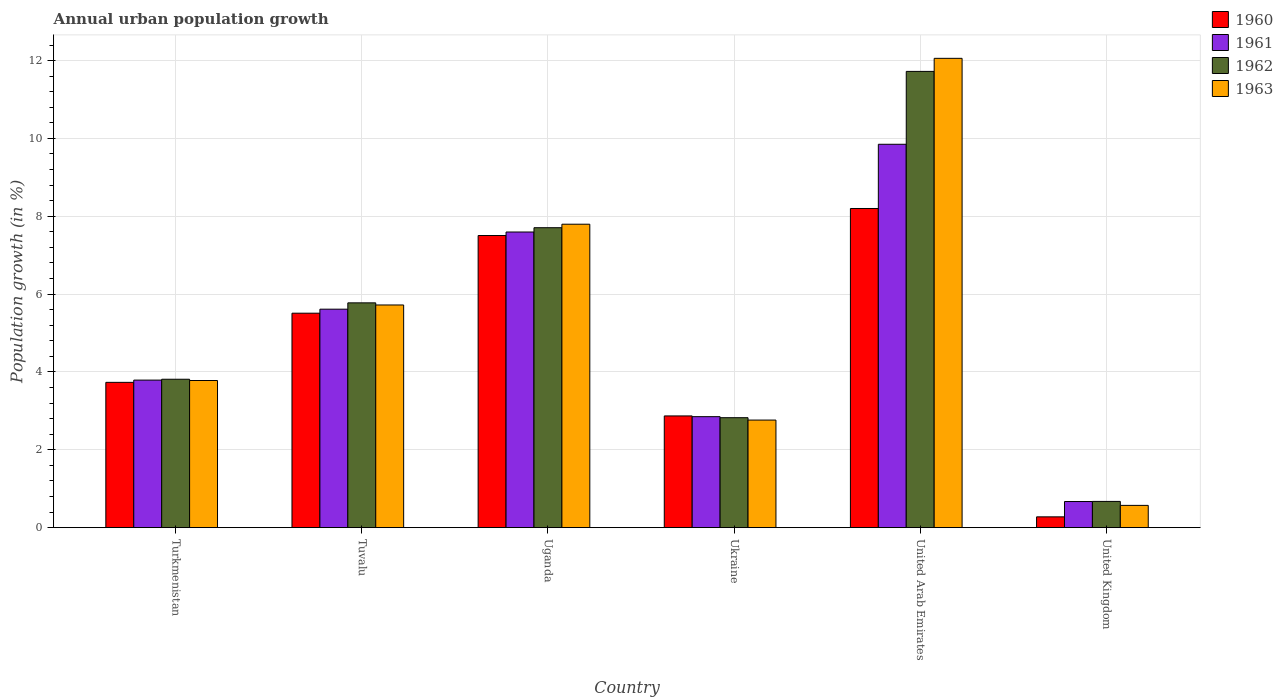How many different coloured bars are there?
Ensure brevity in your answer.  4. Are the number of bars per tick equal to the number of legend labels?
Your answer should be compact. Yes. Are the number of bars on each tick of the X-axis equal?
Make the answer very short. Yes. What is the label of the 2nd group of bars from the left?
Provide a succinct answer. Tuvalu. What is the percentage of urban population growth in 1960 in Ukraine?
Your answer should be compact. 2.87. Across all countries, what is the maximum percentage of urban population growth in 1962?
Offer a very short reply. 11.72. Across all countries, what is the minimum percentage of urban population growth in 1960?
Offer a terse response. 0.28. In which country was the percentage of urban population growth in 1963 maximum?
Provide a short and direct response. United Arab Emirates. What is the total percentage of urban population growth in 1963 in the graph?
Keep it short and to the point. 32.69. What is the difference between the percentage of urban population growth in 1963 in Ukraine and that in United Arab Emirates?
Give a very brief answer. -9.29. What is the difference between the percentage of urban population growth in 1960 in United Kingdom and the percentage of urban population growth in 1963 in Uganda?
Provide a succinct answer. -7.52. What is the average percentage of urban population growth in 1960 per country?
Provide a succinct answer. 4.68. What is the difference between the percentage of urban population growth of/in 1961 and percentage of urban population growth of/in 1963 in Ukraine?
Ensure brevity in your answer.  0.09. In how many countries, is the percentage of urban population growth in 1961 greater than 6 %?
Provide a short and direct response. 2. What is the ratio of the percentage of urban population growth in 1963 in Uganda to that in Ukraine?
Your answer should be compact. 2.82. What is the difference between the highest and the second highest percentage of urban population growth in 1962?
Your answer should be compact. 5.95. What is the difference between the highest and the lowest percentage of urban population growth in 1962?
Keep it short and to the point. 11.05. Is the sum of the percentage of urban population growth in 1963 in Turkmenistan and Ukraine greater than the maximum percentage of urban population growth in 1960 across all countries?
Offer a very short reply. No. What does the 4th bar from the left in United Kingdom represents?
Offer a very short reply. 1963. What does the 1st bar from the right in Turkmenistan represents?
Provide a succinct answer. 1963. How many countries are there in the graph?
Your response must be concise. 6. What is the difference between two consecutive major ticks on the Y-axis?
Your answer should be very brief. 2. Are the values on the major ticks of Y-axis written in scientific E-notation?
Provide a succinct answer. No. How many legend labels are there?
Ensure brevity in your answer.  4. How are the legend labels stacked?
Offer a very short reply. Vertical. What is the title of the graph?
Offer a terse response. Annual urban population growth. What is the label or title of the X-axis?
Provide a short and direct response. Country. What is the label or title of the Y-axis?
Provide a succinct answer. Population growth (in %). What is the Population growth (in %) of 1960 in Turkmenistan?
Your response must be concise. 3.73. What is the Population growth (in %) in 1961 in Turkmenistan?
Offer a very short reply. 3.79. What is the Population growth (in %) in 1962 in Turkmenistan?
Make the answer very short. 3.81. What is the Population growth (in %) in 1963 in Turkmenistan?
Make the answer very short. 3.78. What is the Population growth (in %) of 1960 in Tuvalu?
Offer a very short reply. 5.51. What is the Population growth (in %) in 1961 in Tuvalu?
Ensure brevity in your answer.  5.61. What is the Population growth (in %) of 1962 in Tuvalu?
Provide a short and direct response. 5.78. What is the Population growth (in %) of 1963 in Tuvalu?
Your answer should be very brief. 5.72. What is the Population growth (in %) of 1960 in Uganda?
Ensure brevity in your answer.  7.51. What is the Population growth (in %) in 1961 in Uganda?
Provide a succinct answer. 7.6. What is the Population growth (in %) in 1962 in Uganda?
Your answer should be very brief. 7.71. What is the Population growth (in %) in 1963 in Uganda?
Offer a terse response. 7.8. What is the Population growth (in %) of 1960 in Ukraine?
Provide a succinct answer. 2.87. What is the Population growth (in %) of 1961 in Ukraine?
Your answer should be compact. 2.85. What is the Population growth (in %) of 1962 in Ukraine?
Give a very brief answer. 2.82. What is the Population growth (in %) of 1963 in Ukraine?
Offer a terse response. 2.76. What is the Population growth (in %) of 1960 in United Arab Emirates?
Provide a succinct answer. 8.2. What is the Population growth (in %) in 1961 in United Arab Emirates?
Provide a short and direct response. 9.85. What is the Population growth (in %) of 1962 in United Arab Emirates?
Provide a short and direct response. 11.72. What is the Population growth (in %) of 1963 in United Arab Emirates?
Your answer should be very brief. 12.06. What is the Population growth (in %) of 1960 in United Kingdom?
Make the answer very short. 0.28. What is the Population growth (in %) of 1961 in United Kingdom?
Make the answer very short. 0.67. What is the Population growth (in %) in 1962 in United Kingdom?
Offer a terse response. 0.67. What is the Population growth (in %) of 1963 in United Kingdom?
Your response must be concise. 0.57. Across all countries, what is the maximum Population growth (in %) of 1960?
Offer a very short reply. 8.2. Across all countries, what is the maximum Population growth (in %) in 1961?
Your answer should be very brief. 9.85. Across all countries, what is the maximum Population growth (in %) in 1962?
Your answer should be very brief. 11.72. Across all countries, what is the maximum Population growth (in %) of 1963?
Provide a succinct answer. 12.06. Across all countries, what is the minimum Population growth (in %) in 1960?
Offer a terse response. 0.28. Across all countries, what is the minimum Population growth (in %) of 1961?
Offer a terse response. 0.67. Across all countries, what is the minimum Population growth (in %) of 1962?
Your answer should be very brief. 0.67. Across all countries, what is the minimum Population growth (in %) of 1963?
Make the answer very short. 0.57. What is the total Population growth (in %) of 1960 in the graph?
Provide a succinct answer. 28.1. What is the total Population growth (in %) of 1961 in the graph?
Keep it short and to the point. 30.37. What is the total Population growth (in %) in 1962 in the graph?
Keep it short and to the point. 32.51. What is the total Population growth (in %) in 1963 in the graph?
Offer a very short reply. 32.69. What is the difference between the Population growth (in %) of 1960 in Turkmenistan and that in Tuvalu?
Keep it short and to the point. -1.78. What is the difference between the Population growth (in %) in 1961 in Turkmenistan and that in Tuvalu?
Make the answer very short. -1.82. What is the difference between the Population growth (in %) in 1962 in Turkmenistan and that in Tuvalu?
Keep it short and to the point. -1.96. What is the difference between the Population growth (in %) of 1963 in Turkmenistan and that in Tuvalu?
Your response must be concise. -1.94. What is the difference between the Population growth (in %) of 1960 in Turkmenistan and that in Uganda?
Offer a terse response. -3.77. What is the difference between the Population growth (in %) in 1961 in Turkmenistan and that in Uganda?
Provide a succinct answer. -3.8. What is the difference between the Population growth (in %) of 1962 in Turkmenistan and that in Uganda?
Offer a terse response. -3.89. What is the difference between the Population growth (in %) of 1963 in Turkmenistan and that in Uganda?
Your answer should be compact. -4.02. What is the difference between the Population growth (in %) in 1960 in Turkmenistan and that in Ukraine?
Ensure brevity in your answer.  0.86. What is the difference between the Population growth (in %) in 1961 in Turkmenistan and that in Ukraine?
Offer a very short reply. 0.94. What is the difference between the Population growth (in %) of 1962 in Turkmenistan and that in Ukraine?
Give a very brief answer. 0.99. What is the difference between the Population growth (in %) of 1963 in Turkmenistan and that in Ukraine?
Your answer should be compact. 1.02. What is the difference between the Population growth (in %) in 1960 in Turkmenistan and that in United Arab Emirates?
Provide a succinct answer. -4.47. What is the difference between the Population growth (in %) in 1961 in Turkmenistan and that in United Arab Emirates?
Offer a very short reply. -6.06. What is the difference between the Population growth (in %) in 1962 in Turkmenistan and that in United Arab Emirates?
Make the answer very short. -7.91. What is the difference between the Population growth (in %) in 1963 in Turkmenistan and that in United Arab Emirates?
Keep it short and to the point. -8.28. What is the difference between the Population growth (in %) of 1960 in Turkmenistan and that in United Kingdom?
Offer a terse response. 3.46. What is the difference between the Population growth (in %) in 1961 in Turkmenistan and that in United Kingdom?
Your answer should be compact. 3.12. What is the difference between the Population growth (in %) in 1962 in Turkmenistan and that in United Kingdom?
Your response must be concise. 3.14. What is the difference between the Population growth (in %) in 1963 in Turkmenistan and that in United Kingdom?
Provide a succinct answer. 3.21. What is the difference between the Population growth (in %) in 1960 in Tuvalu and that in Uganda?
Your answer should be compact. -2. What is the difference between the Population growth (in %) of 1961 in Tuvalu and that in Uganda?
Keep it short and to the point. -1.98. What is the difference between the Population growth (in %) of 1962 in Tuvalu and that in Uganda?
Provide a succinct answer. -1.93. What is the difference between the Population growth (in %) in 1963 in Tuvalu and that in Uganda?
Provide a short and direct response. -2.08. What is the difference between the Population growth (in %) in 1960 in Tuvalu and that in Ukraine?
Ensure brevity in your answer.  2.64. What is the difference between the Population growth (in %) of 1961 in Tuvalu and that in Ukraine?
Offer a terse response. 2.76. What is the difference between the Population growth (in %) of 1962 in Tuvalu and that in Ukraine?
Offer a very short reply. 2.95. What is the difference between the Population growth (in %) of 1963 in Tuvalu and that in Ukraine?
Make the answer very short. 2.96. What is the difference between the Population growth (in %) of 1960 in Tuvalu and that in United Arab Emirates?
Your answer should be very brief. -2.69. What is the difference between the Population growth (in %) in 1961 in Tuvalu and that in United Arab Emirates?
Give a very brief answer. -4.24. What is the difference between the Population growth (in %) of 1962 in Tuvalu and that in United Arab Emirates?
Provide a short and direct response. -5.95. What is the difference between the Population growth (in %) in 1963 in Tuvalu and that in United Arab Emirates?
Your answer should be compact. -6.34. What is the difference between the Population growth (in %) in 1960 in Tuvalu and that in United Kingdom?
Make the answer very short. 5.23. What is the difference between the Population growth (in %) in 1961 in Tuvalu and that in United Kingdom?
Offer a terse response. 4.94. What is the difference between the Population growth (in %) in 1962 in Tuvalu and that in United Kingdom?
Your response must be concise. 5.1. What is the difference between the Population growth (in %) in 1963 in Tuvalu and that in United Kingdom?
Provide a succinct answer. 5.15. What is the difference between the Population growth (in %) in 1960 in Uganda and that in Ukraine?
Ensure brevity in your answer.  4.64. What is the difference between the Population growth (in %) in 1961 in Uganda and that in Ukraine?
Keep it short and to the point. 4.74. What is the difference between the Population growth (in %) in 1962 in Uganda and that in Ukraine?
Give a very brief answer. 4.88. What is the difference between the Population growth (in %) of 1963 in Uganda and that in Ukraine?
Offer a very short reply. 5.03. What is the difference between the Population growth (in %) in 1960 in Uganda and that in United Arab Emirates?
Your answer should be very brief. -0.69. What is the difference between the Population growth (in %) in 1961 in Uganda and that in United Arab Emirates?
Provide a short and direct response. -2.25. What is the difference between the Population growth (in %) of 1962 in Uganda and that in United Arab Emirates?
Provide a succinct answer. -4.02. What is the difference between the Population growth (in %) in 1963 in Uganda and that in United Arab Emirates?
Provide a succinct answer. -4.26. What is the difference between the Population growth (in %) of 1960 in Uganda and that in United Kingdom?
Your response must be concise. 7.23. What is the difference between the Population growth (in %) of 1961 in Uganda and that in United Kingdom?
Provide a short and direct response. 6.92. What is the difference between the Population growth (in %) of 1962 in Uganda and that in United Kingdom?
Your answer should be compact. 7.03. What is the difference between the Population growth (in %) of 1963 in Uganda and that in United Kingdom?
Provide a short and direct response. 7.22. What is the difference between the Population growth (in %) in 1960 in Ukraine and that in United Arab Emirates?
Give a very brief answer. -5.33. What is the difference between the Population growth (in %) in 1961 in Ukraine and that in United Arab Emirates?
Your response must be concise. -7. What is the difference between the Population growth (in %) in 1962 in Ukraine and that in United Arab Emirates?
Ensure brevity in your answer.  -8.9. What is the difference between the Population growth (in %) of 1963 in Ukraine and that in United Arab Emirates?
Provide a short and direct response. -9.29. What is the difference between the Population growth (in %) in 1960 in Ukraine and that in United Kingdom?
Make the answer very short. 2.59. What is the difference between the Population growth (in %) of 1961 in Ukraine and that in United Kingdom?
Give a very brief answer. 2.18. What is the difference between the Population growth (in %) in 1962 in Ukraine and that in United Kingdom?
Provide a succinct answer. 2.15. What is the difference between the Population growth (in %) of 1963 in Ukraine and that in United Kingdom?
Your response must be concise. 2.19. What is the difference between the Population growth (in %) of 1960 in United Arab Emirates and that in United Kingdom?
Your answer should be compact. 7.92. What is the difference between the Population growth (in %) of 1961 in United Arab Emirates and that in United Kingdom?
Your answer should be compact. 9.18. What is the difference between the Population growth (in %) of 1962 in United Arab Emirates and that in United Kingdom?
Your answer should be very brief. 11.05. What is the difference between the Population growth (in %) of 1963 in United Arab Emirates and that in United Kingdom?
Provide a succinct answer. 11.49. What is the difference between the Population growth (in %) in 1960 in Turkmenistan and the Population growth (in %) in 1961 in Tuvalu?
Your answer should be very brief. -1.88. What is the difference between the Population growth (in %) of 1960 in Turkmenistan and the Population growth (in %) of 1962 in Tuvalu?
Keep it short and to the point. -2.04. What is the difference between the Population growth (in %) of 1960 in Turkmenistan and the Population growth (in %) of 1963 in Tuvalu?
Offer a terse response. -1.99. What is the difference between the Population growth (in %) of 1961 in Turkmenistan and the Population growth (in %) of 1962 in Tuvalu?
Your answer should be very brief. -1.98. What is the difference between the Population growth (in %) in 1961 in Turkmenistan and the Population growth (in %) in 1963 in Tuvalu?
Your answer should be compact. -1.93. What is the difference between the Population growth (in %) in 1962 in Turkmenistan and the Population growth (in %) in 1963 in Tuvalu?
Make the answer very short. -1.91. What is the difference between the Population growth (in %) in 1960 in Turkmenistan and the Population growth (in %) in 1961 in Uganda?
Offer a terse response. -3.86. What is the difference between the Population growth (in %) of 1960 in Turkmenistan and the Population growth (in %) of 1962 in Uganda?
Offer a very short reply. -3.97. What is the difference between the Population growth (in %) in 1960 in Turkmenistan and the Population growth (in %) in 1963 in Uganda?
Your answer should be very brief. -4.06. What is the difference between the Population growth (in %) in 1961 in Turkmenistan and the Population growth (in %) in 1962 in Uganda?
Offer a terse response. -3.92. What is the difference between the Population growth (in %) in 1961 in Turkmenistan and the Population growth (in %) in 1963 in Uganda?
Give a very brief answer. -4.01. What is the difference between the Population growth (in %) of 1962 in Turkmenistan and the Population growth (in %) of 1963 in Uganda?
Offer a very short reply. -3.98. What is the difference between the Population growth (in %) in 1960 in Turkmenistan and the Population growth (in %) in 1961 in Ukraine?
Your answer should be compact. 0.88. What is the difference between the Population growth (in %) in 1960 in Turkmenistan and the Population growth (in %) in 1962 in Ukraine?
Give a very brief answer. 0.91. What is the difference between the Population growth (in %) of 1960 in Turkmenistan and the Population growth (in %) of 1963 in Ukraine?
Your response must be concise. 0.97. What is the difference between the Population growth (in %) of 1961 in Turkmenistan and the Population growth (in %) of 1962 in Ukraine?
Give a very brief answer. 0.97. What is the difference between the Population growth (in %) in 1962 in Turkmenistan and the Population growth (in %) in 1963 in Ukraine?
Offer a terse response. 1.05. What is the difference between the Population growth (in %) in 1960 in Turkmenistan and the Population growth (in %) in 1961 in United Arab Emirates?
Offer a terse response. -6.12. What is the difference between the Population growth (in %) of 1960 in Turkmenistan and the Population growth (in %) of 1962 in United Arab Emirates?
Give a very brief answer. -7.99. What is the difference between the Population growth (in %) of 1960 in Turkmenistan and the Population growth (in %) of 1963 in United Arab Emirates?
Your answer should be compact. -8.32. What is the difference between the Population growth (in %) in 1961 in Turkmenistan and the Population growth (in %) in 1962 in United Arab Emirates?
Offer a terse response. -7.93. What is the difference between the Population growth (in %) of 1961 in Turkmenistan and the Population growth (in %) of 1963 in United Arab Emirates?
Make the answer very short. -8.27. What is the difference between the Population growth (in %) of 1962 in Turkmenistan and the Population growth (in %) of 1963 in United Arab Emirates?
Ensure brevity in your answer.  -8.24. What is the difference between the Population growth (in %) in 1960 in Turkmenistan and the Population growth (in %) in 1961 in United Kingdom?
Your answer should be compact. 3.06. What is the difference between the Population growth (in %) in 1960 in Turkmenistan and the Population growth (in %) in 1962 in United Kingdom?
Keep it short and to the point. 3.06. What is the difference between the Population growth (in %) of 1960 in Turkmenistan and the Population growth (in %) of 1963 in United Kingdom?
Give a very brief answer. 3.16. What is the difference between the Population growth (in %) of 1961 in Turkmenistan and the Population growth (in %) of 1962 in United Kingdom?
Ensure brevity in your answer.  3.12. What is the difference between the Population growth (in %) of 1961 in Turkmenistan and the Population growth (in %) of 1963 in United Kingdom?
Your response must be concise. 3.22. What is the difference between the Population growth (in %) in 1962 in Turkmenistan and the Population growth (in %) in 1963 in United Kingdom?
Your answer should be very brief. 3.24. What is the difference between the Population growth (in %) of 1960 in Tuvalu and the Population growth (in %) of 1961 in Uganda?
Your response must be concise. -2.09. What is the difference between the Population growth (in %) in 1960 in Tuvalu and the Population growth (in %) in 1962 in Uganda?
Offer a terse response. -2.2. What is the difference between the Population growth (in %) of 1960 in Tuvalu and the Population growth (in %) of 1963 in Uganda?
Keep it short and to the point. -2.29. What is the difference between the Population growth (in %) in 1961 in Tuvalu and the Population growth (in %) in 1962 in Uganda?
Offer a very short reply. -2.09. What is the difference between the Population growth (in %) in 1961 in Tuvalu and the Population growth (in %) in 1963 in Uganda?
Offer a terse response. -2.18. What is the difference between the Population growth (in %) in 1962 in Tuvalu and the Population growth (in %) in 1963 in Uganda?
Offer a very short reply. -2.02. What is the difference between the Population growth (in %) of 1960 in Tuvalu and the Population growth (in %) of 1961 in Ukraine?
Provide a short and direct response. 2.66. What is the difference between the Population growth (in %) of 1960 in Tuvalu and the Population growth (in %) of 1962 in Ukraine?
Give a very brief answer. 2.69. What is the difference between the Population growth (in %) in 1960 in Tuvalu and the Population growth (in %) in 1963 in Ukraine?
Provide a succinct answer. 2.75. What is the difference between the Population growth (in %) of 1961 in Tuvalu and the Population growth (in %) of 1962 in Ukraine?
Keep it short and to the point. 2.79. What is the difference between the Population growth (in %) of 1961 in Tuvalu and the Population growth (in %) of 1963 in Ukraine?
Your response must be concise. 2.85. What is the difference between the Population growth (in %) in 1962 in Tuvalu and the Population growth (in %) in 1963 in Ukraine?
Your answer should be compact. 3.01. What is the difference between the Population growth (in %) in 1960 in Tuvalu and the Population growth (in %) in 1961 in United Arab Emirates?
Make the answer very short. -4.34. What is the difference between the Population growth (in %) in 1960 in Tuvalu and the Population growth (in %) in 1962 in United Arab Emirates?
Provide a succinct answer. -6.21. What is the difference between the Population growth (in %) of 1960 in Tuvalu and the Population growth (in %) of 1963 in United Arab Emirates?
Your response must be concise. -6.55. What is the difference between the Population growth (in %) in 1961 in Tuvalu and the Population growth (in %) in 1962 in United Arab Emirates?
Keep it short and to the point. -6.11. What is the difference between the Population growth (in %) of 1961 in Tuvalu and the Population growth (in %) of 1963 in United Arab Emirates?
Offer a terse response. -6.44. What is the difference between the Population growth (in %) of 1962 in Tuvalu and the Population growth (in %) of 1963 in United Arab Emirates?
Provide a short and direct response. -6.28. What is the difference between the Population growth (in %) in 1960 in Tuvalu and the Population growth (in %) in 1961 in United Kingdom?
Offer a terse response. 4.84. What is the difference between the Population growth (in %) in 1960 in Tuvalu and the Population growth (in %) in 1962 in United Kingdom?
Offer a very short reply. 4.84. What is the difference between the Population growth (in %) of 1960 in Tuvalu and the Population growth (in %) of 1963 in United Kingdom?
Your answer should be compact. 4.94. What is the difference between the Population growth (in %) of 1961 in Tuvalu and the Population growth (in %) of 1962 in United Kingdom?
Your response must be concise. 4.94. What is the difference between the Population growth (in %) in 1961 in Tuvalu and the Population growth (in %) in 1963 in United Kingdom?
Provide a short and direct response. 5.04. What is the difference between the Population growth (in %) in 1962 in Tuvalu and the Population growth (in %) in 1963 in United Kingdom?
Give a very brief answer. 5.2. What is the difference between the Population growth (in %) in 1960 in Uganda and the Population growth (in %) in 1961 in Ukraine?
Your answer should be compact. 4.65. What is the difference between the Population growth (in %) of 1960 in Uganda and the Population growth (in %) of 1962 in Ukraine?
Provide a succinct answer. 4.68. What is the difference between the Population growth (in %) of 1960 in Uganda and the Population growth (in %) of 1963 in Ukraine?
Offer a very short reply. 4.74. What is the difference between the Population growth (in %) in 1961 in Uganda and the Population growth (in %) in 1962 in Ukraine?
Ensure brevity in your answer.  4.77. What is the difference between the Population growth (in %) in 1961 in Uganda and the Population growth (in %) in 1963 in Ukraine?
Offer a terse response. 4.83. What is the difference between the Population growth (in %) in 1962 in Uganda and the Population growth (in %) in 1963 in Ukraine?
Offer a very short reply. 4.94. What is the difference between the Population growth (in %) of 1960 in Uganda and the Population growth (in %) of 1961 in United Arab Emirates?
Ensure brevity in your answer.  -2.34. What is the difference between the Population growth (in %) in 1960 in Uganda and the Population growth (in %) in 1962 in United Arab Emirates?
Keep it short and to the point. -4.22. What is the difference between the Population growth (in %) of 1960 in Uganda and the Population growth (in %) of 1963 in United Arab Emirates?
Provide a short and direct response. -4.55. What is the difference between the Population growth (in %) of 1961 in Uganda and the Population growth (in %) of 1962 in United Arab Emirates?
Make the answer very short. -4.13. What is the difference between the Population growth (in %) of 1961 in Uganda and the Population growth (in %) of 1963 in United Arab Emirates?
Ensure brevity in your answer.  -4.46. What is the difference between the Population growth (in %) of 1962 in Uganda and the Population growth (in %) of 1963 in United Arab Emirates?
Keep it short and to the point. -4.35. What is the difference between the Population growth (in %) of 1960 in Uganda and the Population growth (in %) of 1961 in United Kingdom?
Your answer should be very brief. 6.83. What is the difference between the Population growth (in %) of 1960 in Uganda and the Population growth (in %) of 1962 in United Kingdom?
Your answer should be very brief. 6.83. What is the difference between the Population growth (in %) of 1960 in Uganda and the Population growth (in %) of 1963 in United Kingdom?
Your answer should be very brief. 6.93. What is the difference between the Population growth (in %) of 1961 in Uganda and the Population growth (in %) of 1962 in United Kingdom?
Offer a very short reply. 6.92. What is the difference between the Population growth (in %) in 1961 in Uganda and the Population growth (in %) in 1963 in United Kingdom?
Ensure brevity in your answer.  7.02. What is the difference between the Population growth (in %) in 1962 in Uganda and the Population growth (in %) in 1963 in United Kingdom?
Make the answer very short. 7.13. What is the difference between the Population growth (in %) of 1960 in Ukraine and the Population growth (in %) of 1961 in United Arab Emirates?
Give a very brief answer. -6.98. What is the difference between the Population growth (in %) of 1960 in Ukraine and the Population growth (in %) of 1962 in United Arab Emirates?
Make the answer very short. -8.85. What is the difference between the Population growth (in %) in 1960 in Ukraine and the Population growth (in %) in 1963 in United Arab Emirates?
Ensure brevity in your answer.  -9.19. What is the difference between the Population growth (in %) in 1961 in Ukraine and the Population growth (in %) in 1962 in United Arab Emirates?
Ensure brevity in your answer.  -8.87. What is the difference between the Population growth (in %) in 1961 in Ukraine and the Population growth (in %) in 1963 in United Arab Emirates?
Make the answer very short. -9.21. What is the difference between the Population growth (in %) in 1962 in Ukraine and the Population growth (in %) in 1963 in United Arab Emirates?
Your answer should be compact. -9.23. What is the difference between the Population growth (in %) in 1960 in Ukraine and the Population growth (in %) in 1961 in United Kingdom?
Provide a succinct answer. 2.2. What is the difference between the Population growth (in %) in 1960 in Ukraine and the Population growth (in %) in 1962 in United Kingdom?
Your response must be concise. 2.2. What is the difference between the Population growth (in %) in 1960 in Ukraine and the Population growth (in %) in 1963 in United Kingdom?
Ensure brevity in your answer.  2.3. What is the difference between the Population growth (in %) of 1961 in Ukraine and the Population growth (in %) of 1962 in United Kingdom?
Provide a succinct answer. 2.18. What is the difference between the Population growth (in %) in 1961 in Ukraine and the Population growth (in %) in 1963 in United Kingdom?
Provide a succinct answer. 2.28. What is the difference between the Population growth (in %) in 1962 in Ukraine and the Population growth (in %) in 1963 in United Kingdom?
Your answer should be very brief. 2.25. What is the difference between the Population growth (in %) in 1960 in United Arab Emirates and the Population growth (in %) in 1961 in United Kingdom?
Keep it short and to the point. 7.53. What is the difference between the Population growth (in %) of 1960 in United Arab Emirates and the Population growth (in %) of 1962 in United Kingdom?
Your answer should be very brief. 7.53. What is the difference between the Population growth (in %) in 1960 in United Arab Emirates and the Population growth (in %) in 1963 in United Kingdom?
Provide a short and direct response. 7.63. What is the difference between the Population growth (in %) in 1961 in United Arab Emirates and the Population growth (in %) in 1962 in United Kingdom?
Ensure brevity in your answer.  9.18. What is the difference between the Population growth (in %) in 1961 in United Arab Emirates and the Population growth (in %) in 1963 in United Kingdom?
Offer a terse response. 9.28. What is the difference between the Population growth (in %) in 1962 in United Arab Emirates and the Population growth (in %) in 1963 in United Kingdom?
Your answer should be compact. 11.15. What is the average Population growth (in %) in 1960 per country?
Your answer should be very brief. 4.68. What is the average Population growth (in %) in 1961 per country?
Provide a short and direct response. 5.06. What is the average Population growth (in %) in 1962 per country?
Make the answer very short. 5.42. What is the average Population growth (in %) in 1963 per country?
Your answer should be compact. 5.45. What is the difference between the Population growth (in %) of 1960 and Population growth (in %) of 1961 in Turkmenistan?
Offer a terse response. -0.06. What is the difference between the Population growth (in %) in 1960 and Population growth (in %) in 1962 in Turkmenistan?
Ensure brevity in your answer.  -0.08. What is the difference between the Population growth (in %) of 1960 and Population growth (in %) of 1963 in Turkmenistan?
Make the answer very short. -0.05. What is the difference between the Population growth (in %) in 1961 and Population growth (in %) in 1962 in Turkmenistan?
Your answer should be compact. -0.02. What is the difference between the Population growth (in %) in 1961 and Population growth (in %) in 1963 in Turkmenistan?
Keep it short and to the point. 0.01. What is the difference between the Population growth (in %) in 1962 and Population growth (in %) in 1963 in Turkmenistan?
Your response must be concise. 0.03. What is the difference between the Population growth (in %) in 1960 and Population growth (in %) in 1961 in Tuvalu?
Keep it short and to the point. -0.1. What is the difference between the Population growth (in %) of 1960 and Population growth (in %) of 1962 in Tuvalu?
Offer a terse response. -0.27. What is the difference between the Population growth (in %) in 1960 and Population growth (in %) in 1963 in Tuvalu?
Give a very brief answer. -0.21. What is the difference between the Population growth (in %) of 1961 and Population growth (in %) of 1962 in Tuvalu?
Ensure brevity in your answer.  -0.16. What is the difference between the Population growth (in %) of 1961 and Population growth (in %) of 1963 in Tuvalu?
Give a very brief answer. -0.11. What is the difference between the Population growth (in %) in 1962 and Population growth (in %) in 1963 in Tuvalu?
Provide a succinct answer. 0.05. What is the difference between the Population growth (in %) of 1960 and Population growth (in %) of 1961 in Uganda?
Provide a short and direct response. -0.09. What is the difference between the Population growth (in %) of 1960 and Population growth (in %) of 1962 in Uganda?
Ensure brevity in your answer.  -0.2. What is the difference between the Population growth (in %) of 1960 and Population growth (in %) of 1963 in Uganda?
Provide a succinct answer. -0.29. What is the difference between the Population growth (in %) of 1961 and Population growth (in %) of 1962 in Uganda?
Your answer should be compact. -0.11. What is the difference between the Population growth (in %) of 1961 and Population growth (in %) of 1963 in Uganda?
Give a very brief answer. -0.2. What is the difference between the Population growth (in %) of 1962 and Population growth (in %) of 1963 in Uganda?
Ensure brevity in your answer.  -0.09. What is the difference between the Population growth (in %) of 1960 and Population growth (in %) of 1961 in Ukraine?
Your answer should be very brief. 0.02. What is the difference between the Population growth (in %) of 1960 and Population growth (in %) of 1962 in Ukraine?
Ensure brevity in your answer.  0.05. What is the difference between the Population growth (in %) in 1960 and Population growth (in %) in 1963 in Ukraine?
Ensure brevity in your answer.  0.11. What is the difference between the Population growth (in %) of 1961 and Population growth (in %) of 1962 in Ukraine?
Your answer should be compact. 0.03. What is the difference between the Population growth (in %) in 1961 and Population growth (in %) in 1963 in Ukraine?
Give a very brief answer. 0.09. What is the difference between the Population growth (in %) in 1962 and Population growth (in %) in 1963 in Ukraine?
Provide a short and direct response. 0.06. What is the difference between the Population growth (in %) of 1960 and Population growth (in %) of 1961 in United Arab Emirates?
Make the answer very short. -1.65. What is the difference between the Population growth (in %) of 1960 and Population growth (in %) of 1962 in United Arab Emirates?
Make the answer very short. -3.52. What is the difference between the Population growth (in %) in 1960 and Population growth (in %) in 1963 in United Arab Emirates?
Provide a succinct answer. -3.86. What is the difference between the Population growth (in %) of 1961 and Population growth (in %) of 1962 in United Arab Emirates?
Your answer should be compact. -1.87. What is the difference between the Population growth (in %) of 1961 and Population growth (in %) of 1963 in United Arab Emirates?
Your answer should be very brief. -2.21. What is the difference between the Population growth (in %) of 1962 and Population growth (in %) of 1963 in United Arab Emirates?
Make the answer very short. -0.34. What is the difference between the Population growth (in %) in 1960 and Population growth (in %) in 1961 in United Kingdom?
Provide a short and direct response. -0.39. What is the difference between the Population growth (in %) in 1960 and Population growth (in %) in 1962 in United Kingdom?
Keep it short and to the point. -0.4. What is the difference between the Population growth (in %) of 1960 and Population growth (in %) of 1963 in United Kingdom?
Provide a short and direct response. -0.29. What is the difference between the Population growth (in %) in 1961 and Population growth (in %) in 1962 in United Kingdom?
Your answer should be compact. -0. What is the difference between the Population growth (in %) in 1961 and Population growth (in %) in 1963 in United Kingdom?
Keep it short and to the point. 0.1. What is the difference between the Population growth (in %) in 1962 and Population growth (in %) in 1963 in United Kingdom?
Provide a succinct answer. 0.1. What is the ratio of the Population growth (in %) of 1960 in Turkmenistan to that in Tuvalu?
Keep it short and to the point. 0.68. What is the ratio of the Population growth (in %) in 1961 in Turkmenistan to that in Tuvalu?
Offer a terse response. 0.68. What is the ratio of the Population growth (in %) in 1962 in Turkmenistan to that in Tuvalu?
Keep it short and to the point. 0.66. What is the ratio of the Population growth (in %) in 1963 in Turkmenistan to that in Tuvalu?
Keep it short and to the point. 0.66. What is the ratio of the Population growth (in %) in 1960 in Turkmenistan to that in Uganda?
Provide a short and direct response. 0.5. What is the ratio of the Population growth (in %) in 1961 in Turkmenistan to that in Uganda?
Your answer should be compact. 0.5. What is the ratio of the Population growth (in %) of 1962 in Turkmenistan to that in Uganda?
Your answer should be very brief. 0.49. What is the ratio of the Population growth (in %) in 1963 in Turkmenistan to that in Uganda?
Offer a terse response. 0.48. What is the ratio of the Population growth (in %) of 1960 in Turkmenistan to that in Ukraine?
Provide a succinct answer. 1.3. What is the ratio of the Population growth (in %) in 1961 in Turkmenistan to that in Ukraine?
Offer a very short reply. 1.33. What is the ratio of the Population growth (in %) in 1962 in Turkmenistan to that in Ukraine?
Ensure brevity in your answer.  1.35. What is the ratio of the Population growth (in %) of 1963 in Turkmenistan to that in Ukraine?
Your answer should be compact. 1.37. What is the ratio of the Population growth (in %) of 1960 in Turkmenistan to that in United Arab Emirates?
Make the answer very short. 0.46. What is the ratio of the Population growth (in %) in 1961 in Turkmenistan to that in United Arab Emirates?
Make the answer very short. 0.38. What is the ratio of the Population growth (in %) of 1962 in Turkmenistan to that in United Arab Emirates?
Provide a short and direct response. 0.33. What is the ratio of the Population growth (in %) of 1963 in Turkmenistan to that in United Arab Emirates?
Provide a succinct answer. 0.31. What is the ratio of the Population growth (in %) in 1960 in Turkmenistan to that in United Kingdom?
Give a very brief answer. 13.46. What is the ratio of the Population growth (in %) of 1961 in Turkmenistan to that in United Kingdom?
Ensure brevity in your answer.  5.65. What is the ratio of the Population growth (in %) of 1962 in Turkmenistan to that in United Kingdom?
Your response must be concise. 5.66. What is the ratio of the Population growth (in %) in 1963 in Turkmenistan to that in United Kingdom?
Keep it short and to the point. 6.61. What is the ratio of the Population growth (in %) in 1960 in Tuvalu to that in Uganda?
Give a very brief answer. 0.73. What is the ratio of the Population growth (in %) of 1961 in Tuvalu to that in Uganda?
Make the answer very short. 0.74. What is the ratio of the Population growth (in %) of 1962 in Tuvalu to that in Uganda?
Keep it short and to the point. 0.75. What is the ratio of the Population growth (in %) in 1963 in Tuvalu to that in Uganda?
Provide a short and direct response. 0.73. What is the ratio of the Population growth (in %) of 1960 in Tuvalu to that in Ukraine?
Provide a succinct answer. 1.92. What is the ratio of the Population growth (in %) in 1961 in Tuvalu to that in Ukraine?
Make the answer very short. 1.97. What is the ratio of the Population growth (in %) in 1962 in Tuvalu to that in Ukraine?
Provide a short and direct response. 2.04. What is the ratio of the Population growth (in %) in 1963 in Tuvalu to that in Ukraine?
Your answer should be compact. 2.07. What is the ratio of the Population growth (in %) in 1960 in Tuvalu to that in United Arab Emirates?
Your answer should be compact. 0.67. What is the ratio of the Population growth (in %) in 1961 in Tuvalu to that in United Arab Emirates?
Offer a terse response. 0.57. What is the ratio of the Population growth (in %) in 1962 in Tuvalu to that in United Arab Emirates?
Your response must be concise. 0.49. What is the ratio of the Population growth (in %) of 1963 in Tuvalu to that in United Arab Emirates?
Provide a short and direct response. 0.47. What is the ratio of the Population growth (in %) of 1960 in Tuvalu to that in United Kingdom?
Keep it short and to the point. 19.87. What is the ratio of the Population growth (in %) of 1961 in Tuvalu to that in United Kingdom?
Your answer should be compact. 8.36. What is the ratio of the Population growth (in %) of 1962 in Tuvalu to that in United Kingdom?
Your response must be concise. 8.57. What is the ratio of the Population growth (in %) in 1963 in Tuvalu to that in United Kingdom?
Give a very brief answer. 10. What is the ratio of the Population growth (in %) in 1960 in Uganda to that in Ukraine?
Offer a very short reply. 2.61. What is the ratio of the Population growth (in %) of 1961 in Uganda to that in Ukraine?
Give a very brief answer. 2.66. What is the ratio of the Population growth (in %) in 1962 in Uganda to that in Ukraine?
Make the answer very short. 2.73. What is the ratio of the Population growth (in %) in 1963 in Uganda to that in Ukraine?
Offer a terse response. 2.82. What is the ratio of the Population growth (in %) of 1960 in Uganda to that in United Arab Emirates?
Keep it short and to the point. 0.92. What is the ratio of the Population growth (in %) in 1961 in Uganda to that in United Arab Emirates?
Provide a succinct answer. 0.77. What is the ratio of the Population growth (in %) in 1962 in Uganda to that in United Arab Emirates?
Offer a terse response. 0.66. What is the ratio of the Population growth (in %) in 1963 in Uganda to that in United Arab Emirates?
Ensure brevity in your answer.  0.65. What is the ratio of the Population growth (in %) in 1960 in Uganda to that in United Kingdom?
Make the answer very short. 27.06. What is the ratio of the Population growth (in %) of 1961 in Uganda to that in United Kingdom?
Offer a very short reply. 11.32. What is the ratio of the Population growth (in %) in 1962 in Uganda to that in United Kingdom?
Make the answer very short. 11.44. What is the ratio of the Population growth (in %) of 1963 in Uganda to that in United Kingdom?
Offer a terse response. 13.63. What is the ratio of the Population growth (in %) in 1961 in Ukraine to that in United Arab Emirates?
Keep it short and to the point. 0.29. What is the ratio of the Population growth (in %) in 1962 in Ukraine to that in United Arab Emirates?
Offer a terse response. 0.24. What is the ratio of the Population growth (in %) in 1963 in Ukraine to that in United Arab Emirates?
Your response must be concise. 0.23. What is the ratio of the Population growth (in %) in 1960 in Ukraine to that in United Kingdom?
Keep it short and to the point. 10.35. What is the ratio of the Population growth (in %) of 1961 in Ukraine to that in United Kingdom?
Ensure brevity in your answer.  4.25. What is the ratio of the Population growth (in %) of 1962 in Ukraine to that in United Kingdom?
Your answer should be very brief. 4.19. What is the ratio of the Population growth (in %) of 1963 in Ukraine to that in United Kingdom?
Your answer should be compact. 4.83. What is the ratio of the Population growth (in %) in 1960 in United Arab Emirates to that in United Kingdom?
Your answer should be very brief. 29.57. What is the ratio of the Population growth (in %) of 1961 in United Arab Emirates to that in United Kingdom?
Make the answer very short. 14.68. What is the ratio of the Population growth (in %) in 1962 in United Arab Emirates to that in United Kingdom?
Ensure brevity in your answer.  17.4. What is the ratio of the Population growth (in %) in 1963 in United Arab Emirates to that in United Kingdom?
Provide a short and direct response. 21.09. What is the difference between the highest and the second highest Population growth (in %) of 1960?
Offer a very short reply. 0.69. What is the difference between the highest and the second highest Population growth (in %) of 1961?
Keep it short and to the point. 2.25. What is the difference between the highest and the second highest Population growth (in %) of 1962?
Give a very brief answer. 4.02. What is the difference between the highest and the second highest Population growth (in %) in 1963?
Your answer should be very brief. 4.26. What is the difference between the highest and the lowest Population growth (in %) of 1960?
Your answer should be compact. 7.92. What is the difference between the highest and the lowest Population growth (in %) of 1961?
Your response must be concise. 9.18. What is the difference between the highest and the lowest Population growth (in %) of 1962?
Ensure brevity in your answer.  11.05. What is the difference between the highest and the lowest Population growth (in %) of 1963?
Provide a short and direct response. 11.49. 